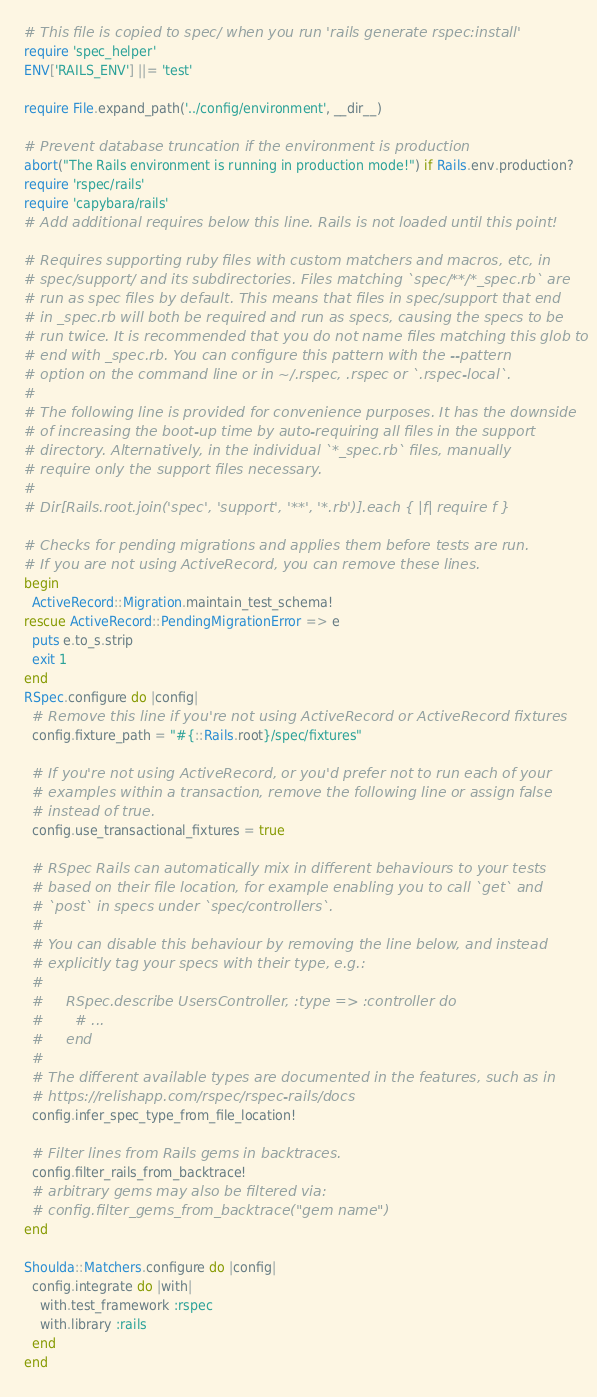Convert code to text. <code><loc_0><loc_0><loc_500><loc_500><_Ruby_># This file is copied to spec/ when you run 'rails generate rspec:install'
require 'spec_helper'
ENV['RAILS_ENV'] ||= 'test'

require File.expand_path('../config/environment', __dir__)

# Prevent database truncation if the environment is production
abort("The Rails environment is running in production mode!") if Rails.env.production?
require 'rspec/rails'
require 'capybara/rails'
# Add additional requires below this line. Rails is not loaded until this point!

# Requires supporting ruby files with custom matchers and macros, etc, in
# spec/support/ and its subdirectories. Files matching `spec/**/*_spec.rb` are
# run as spec files by default. This means that files in spec/support that end
# in _spec.rb will both be required and run as specs, causing the specs to be
# run twice. It is recommended that you do not name files matching this glob to
# end with _spec.rb. You can configure this pattern with the --pattern
# option on the command line or in ~/.rspec, .rspec or `.rspec-local`.
#
# The following line is provided for convenience purposes. It has the downside
# of increasing the boot-up time by auto-requiring all files in the support
# directory. Alternatively, in the individual `*_spec.rb` files, manually
# require only the support files necessary.
#
# Dir[Rails.root.join('spec', 'support', '**', '*.rb')].each { |f| require f }

# Checks for pending migrations and applies them before tests are run.
# If you are not using ActiveRecord, you can remove these lines.
begin
  ActiveRecord::Migration.maintain_test_schema!
rescue ActiveRecord::PendingMigrationError => e
  puts e.to_s.strip
  exit 1
end
RSpec.configure do |config|
  # Remove this line if you're not using ActiveRecord or ActiveRecord fixtures
  config.fixture_path = "#{::Rails.root}/spec/fixtures"

  # If you're not using ActiveRecord, or you'd prefer not to run each of your
  # examples within a transaction, remove the following line or assign false
  # instead of true.
  config.use_transactional_fixtures = true

  # RSpec Rails can automatically mix in different behaviours to your tests
  # based on their file location, for example enabling you to call `get` and
  # `post` in specs under `spec/controllers`.
  #
  # You can disable this behaviour by removing the line below, and instead
  # explicitly tag your specs with their type, e.g.:
  #
  #     RSpec.describe UsersController, :type => :controller do
  #       # ...
  #     end
  #
  # The different available types are documented in the features, such as in
  # https://relishapp.com/rspec/rspec-rails/docs
  config.infer_spec_type_from_file_location!

  # Filter lines from Rails gems in backtraces.
  config.filter_rails_from_backtrace!
  # arbitrary gems may also be filtered via:
  # config.filter_gems_from_backtrace("gem name")
end

Shoulda::Matchers.configure do |config|
  config.integrate do |with|
    with.test_framework :rspec
    with.library :rails
  end
end
</code> 